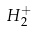<formula> <loc_0><loc_0><loc_500><loc_500>H _ { 2 } ^ { + }</formula> 